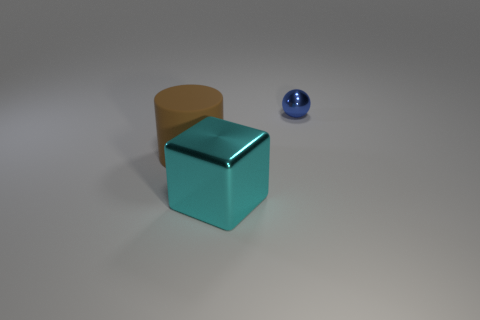Subtract all cyan spheres. Subtract all red cubes. How many spheres are left? 1 Add 2 yellow shiny cubes. How many objects exist? 5 Subtract all cylinders. How many objects are left? 2 Subtract all green metallic blocks. Subtract all large brown rubber objects. How many objects are left? 2 Add 1 blue metallic things. How many blue metallic things are left? 2 Add 1 yellow metallic things. How many yellow metallic things exist? 1 Subtract 0 yellow cubes. How many objects are left? 3 